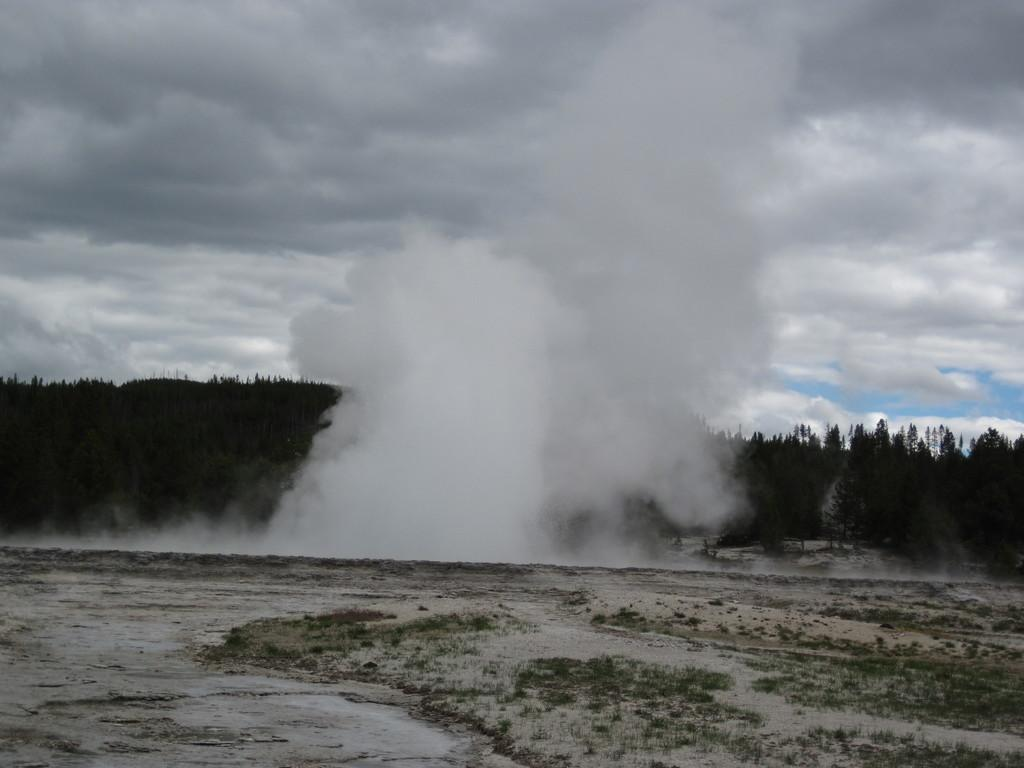What can be seen in the image that indicates some kind of activity or event? There is smoke in the image, which suggests some kind of activity or event is taking place. What type of natural elements are present in the image? There are trees in the image. What can be seen in the distance in the image? The sky is visible in the background of the image. Where is the chair located in the image? There is no chair present in the image. What type of deer can be seen grazing among the trees in the image? There are no deer present in the image; only trees and smoke are visible. 